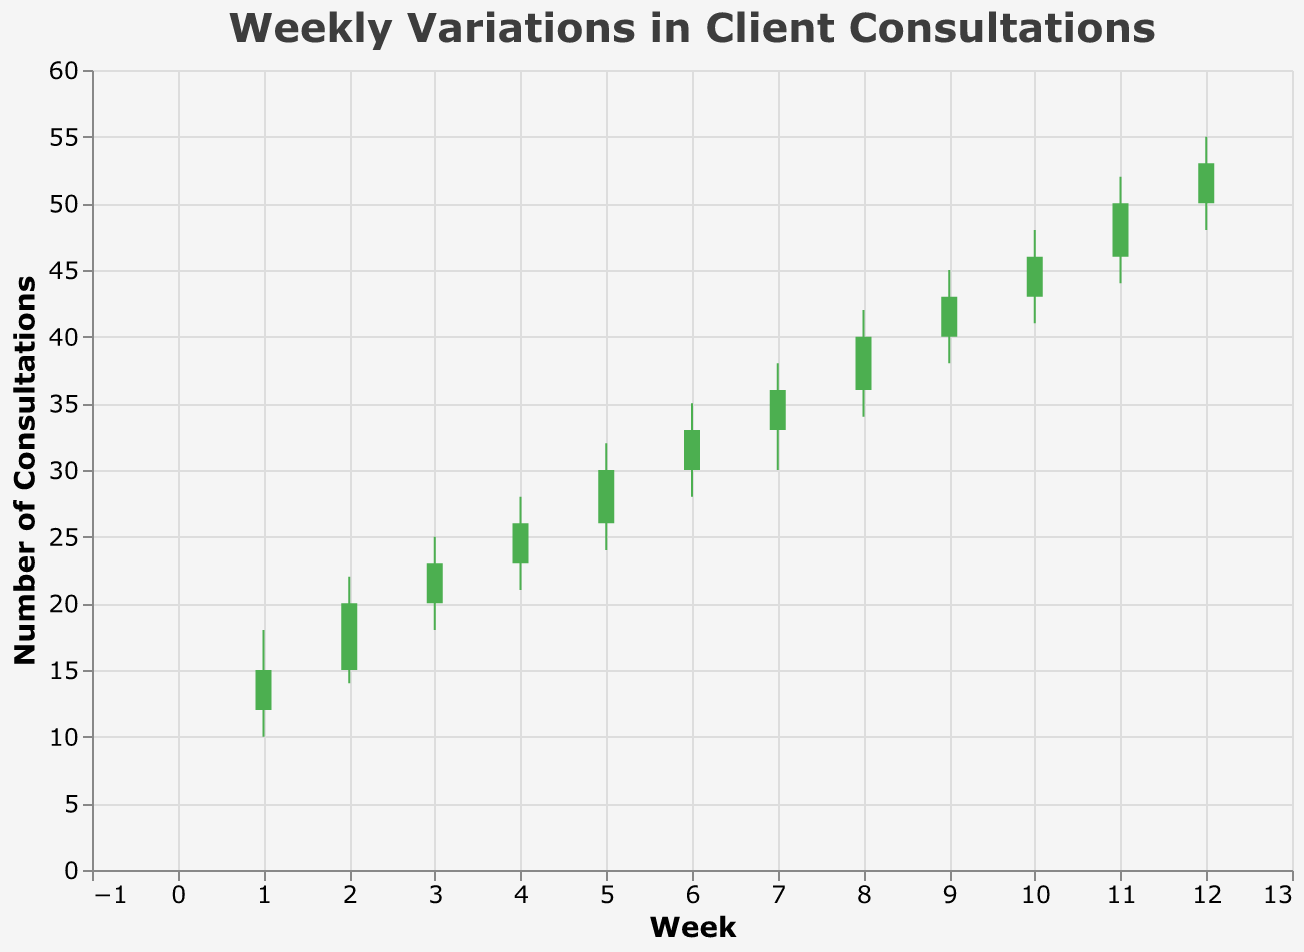What is the title of the figure? The title of a figure typically appears at the top and provides an overview of what the figure is about. In this figure, the title is "Weekly Variations in Client Consultations."
Answer: Weekly Variations in Client Consultations How many weeks of data are represented in the figure? The x-axis, labeled "Week," ranges from week 1 to week 12, indicating the number of weeks shown.
Answer: 12 Which week had the highest number of total consultations? The total consultations can be inferred from the "High" value each week. Week 12 had the highest "High" value, which is 55.
Answer: Week 12 In which weeks did the number of consultations increase compared to the previous week? Consult the "Open" and "Close" values. An increase occurs when the "Close" value of one week is higher than the "Open" value of that week. Weeks 1, 2, 3, 4, 5, 6, 7, 8, 9, 10, and 11 follow this pattern.
Answer: Weeks 1, 2, 3, 4, 5, 6, 7, 8, 9, 10, 11 What is the average number of consultations for the "Close" values throughout the 12 weeks? Sum all the "Close" values: 15 + 20 + 23 + 26 + 30 + 33 + 36 + 40 + 43 + 46 + 50 + 53 = 415. Then, divide by the number of weeks, which is 12. So, 415 / 12 = 34.58
Answer: 34.58 Which week had the biggest range of consultations between the highest and lowest points? To find the range, subtract the "Low" value from the "High" value for each week. Week 12 has the highest range with 55 - 48 = 7.
Answer: Week 12 From weeks 1 to 12, how many times did the consultations decrease within a week? A decrease is indicated when the "Open" value is higher than the "Close" value for a week. According to the chart, there is never a week where the "Open" value is higher than the "Close" value.
Answer: 0 times Which two consecutive weeks show the greatest increase in the "Close" value? Compare the "Close" value of each week with the subsequent week's "Close" value. The greatest increase is between Weeks 11 (Close = 50) and 12 (Close = 53), an increase of 3.
Answer: Between Week 11 and Week 12 What is the maximum number of consultations for a single week? The maximum number of consultations for a single week can be identified by the highest "High" value, which is 55 in Week 12.
Answer: 55 Which week had the smallest difference between the "Open" and "Close" values? Calculate the difference for each week: "Close" minus "Open." Week 3 and Week 5 both have the smallest difference of 3 (23 - 20 = 3 and 30 - 26 = 3).
Answer: Weeks 3 and 5 